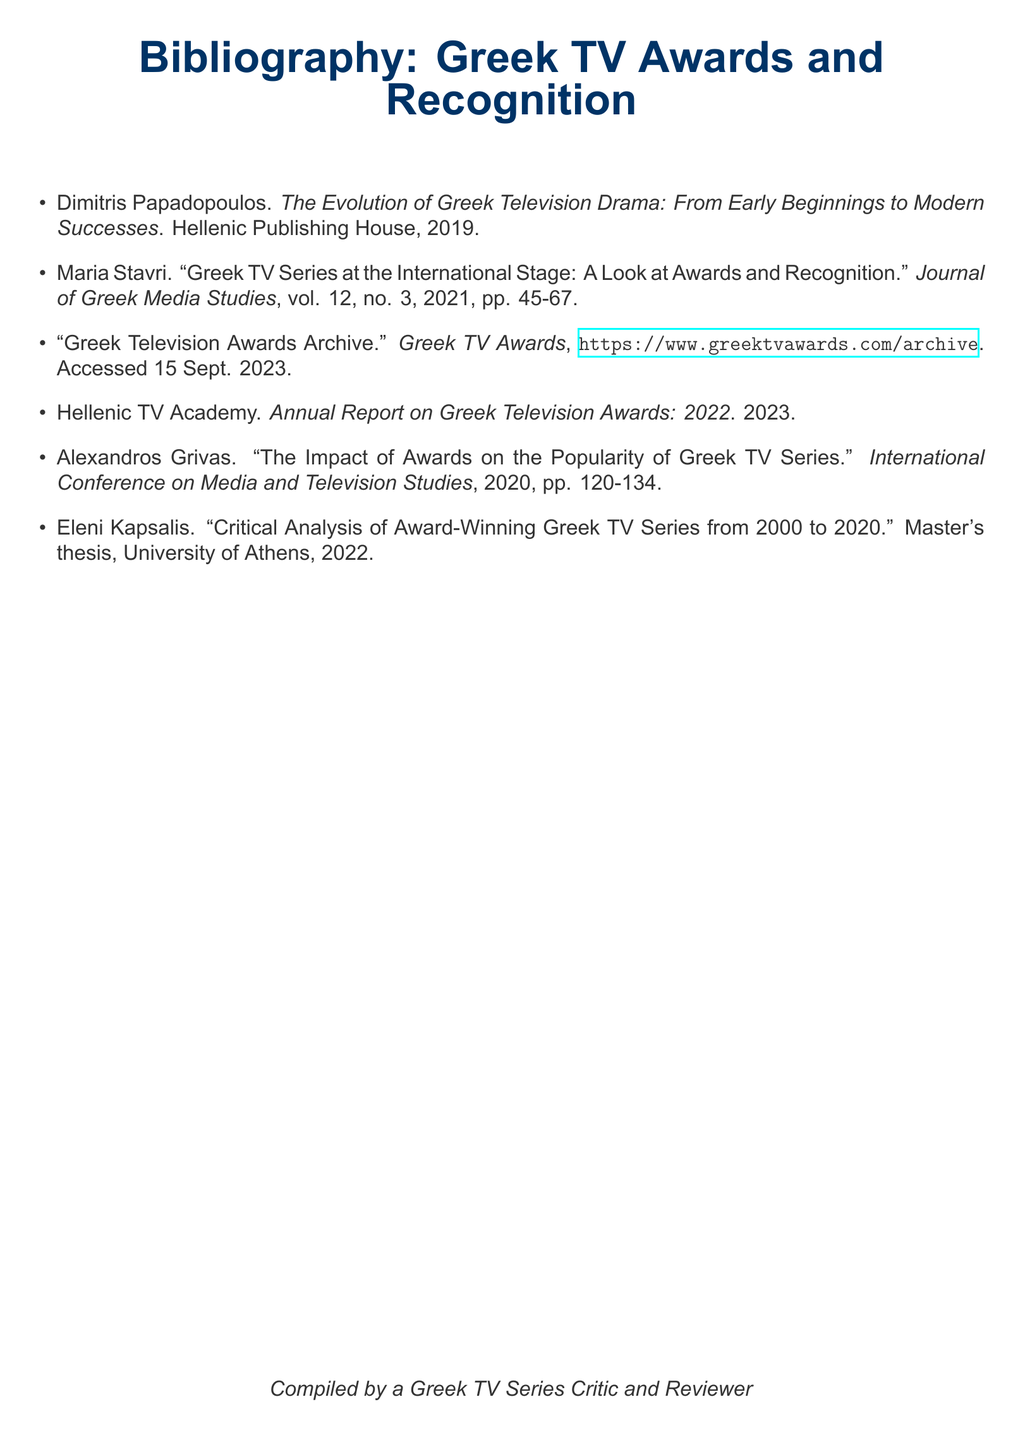What is the title of the book by Dimitris Papadopoulos? The title can be found in the first item of the bibliography, which provides an overview of Greek television drama.
Answer: The Evolution of Greek Television Drama: From Early Beginnings to Modern Successes Who authored the Master's thesis on award-winning Greek TV series? The author of the thesis is listed in the bibliography and focuses on critical analysis from 2000 to 2020.
Answer: Eleni Kapsalis In what year was the annual report on Greek Television Awards published? The annual report is mentioned with its publication year cited directly in the document.
Answer: 2023 What volume and number is Maria Stavri's article published in? The article's volume and number can be directly retrieved from the reference provided in the bibliography.
Answer: vol. 12, no. 3 Which conference did Alexandros Grivas present his work? The conference name is included in the citation for Grivas's work and relates to media and television studies.
Answer: International Conference on Media and Television Studies What organization is responsible for the "Greek Television Awards Archive"? The source of the archive is clearly stated, along with a URL for access, highlighting its provider.
Answer: Greek TV Awards How many items are in the bibliography? The total count of entries in the bibliography offers an overview of the references included.
Answer: 6 What year does Eleni Kapsalis’s thesis date back to? The date can be found in the citation for Kapsalis's thesis within the document.
Answer: 2022 